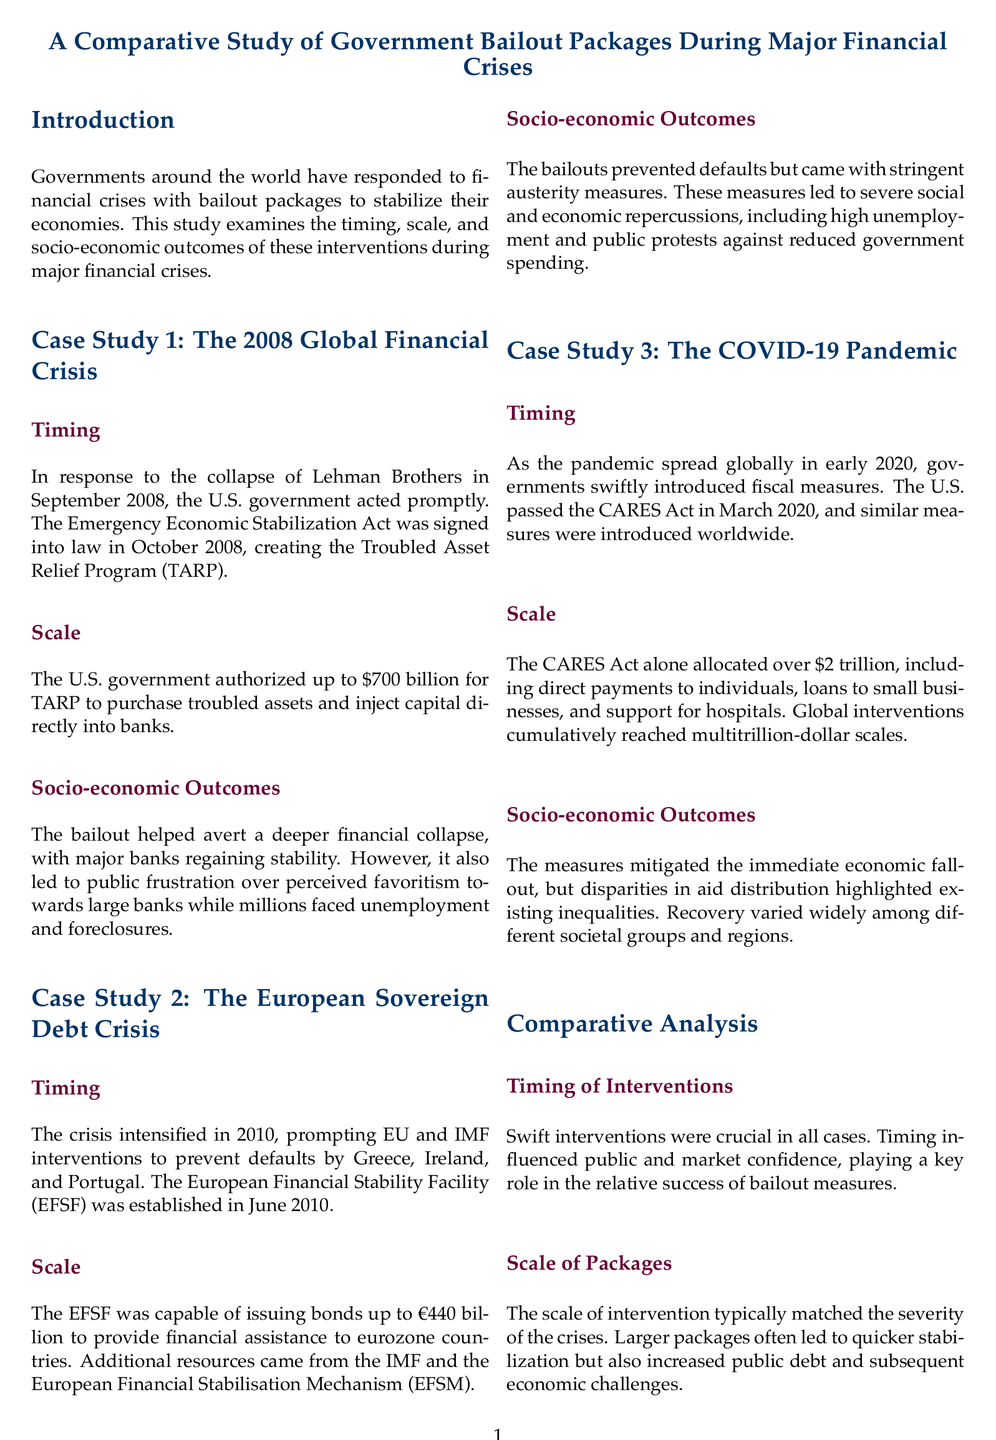what is the total amount authorized for TARP? The total amount authorized for TARP is mentioned in the section on the 2008 Global Financial Crisis, specifically stating up to $700 billion.
Answer: $700 billion what act was signed into law in October 2008? The act signed into law in October 2008, responding to the 2008 financial crisis, is named the Emergency Economic Stabilization Act.
Answer: Emergency Economic Stabilization Act what was the scale of the EFSF? The scale of the EFSF is specified as being capable of issuing bonds up to €440 billion to provide financial assistance.
Answer: €440 billion what year did the COVID-19 pandemic prompt government interventions? The year that governments introduced fiscal measures in response to the COVID-19 pandemic is noted as early 2020.
Answer: 2020 what was a key feature of the socio-economic outcomes from the European Sovereign Debt Crisis interventions? The socio-economic outcomes from the European Sovereign Debt Crisis interventions included stringent austerity measures leading to severe social and economic repercussions.
Answer: stringent austerity measures what was the primary goal of the bailouts? The primary goal of the bailouts during the financial crises was to stabilize the economies and avert financial catastrophes.
Answer: stabilize economies how did the timing of interventions impact public confidence? The timing of interventions is indicated to have influenced public and market confidence, which played a key role in the success of the bailouts.
Answer: influenced public and market confidence what was a notable outcome related to inequalities after the COVID-19 measures? A notable outcome following the COVID-19 measures highlighted disparities in aid distribution, which revealed existing inequalities.
Answer: disparities in aid distribution what does the conclusion suggest about economic policies? The conclusion of the document suggests that there is a need for more equitable economic policies to ensure comprehensive benefits from interventions.
Answer: equitable economic policies 